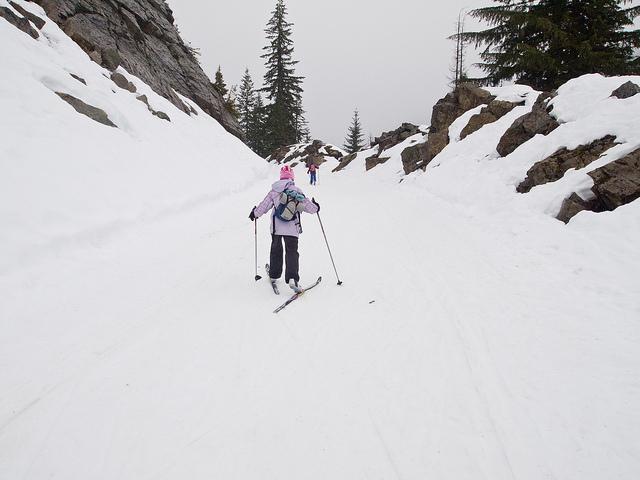How many people can be seen on the trail?
Give a very brief answer. 2. How many skiers are in this photo?
Give a very brief answer. 2. 